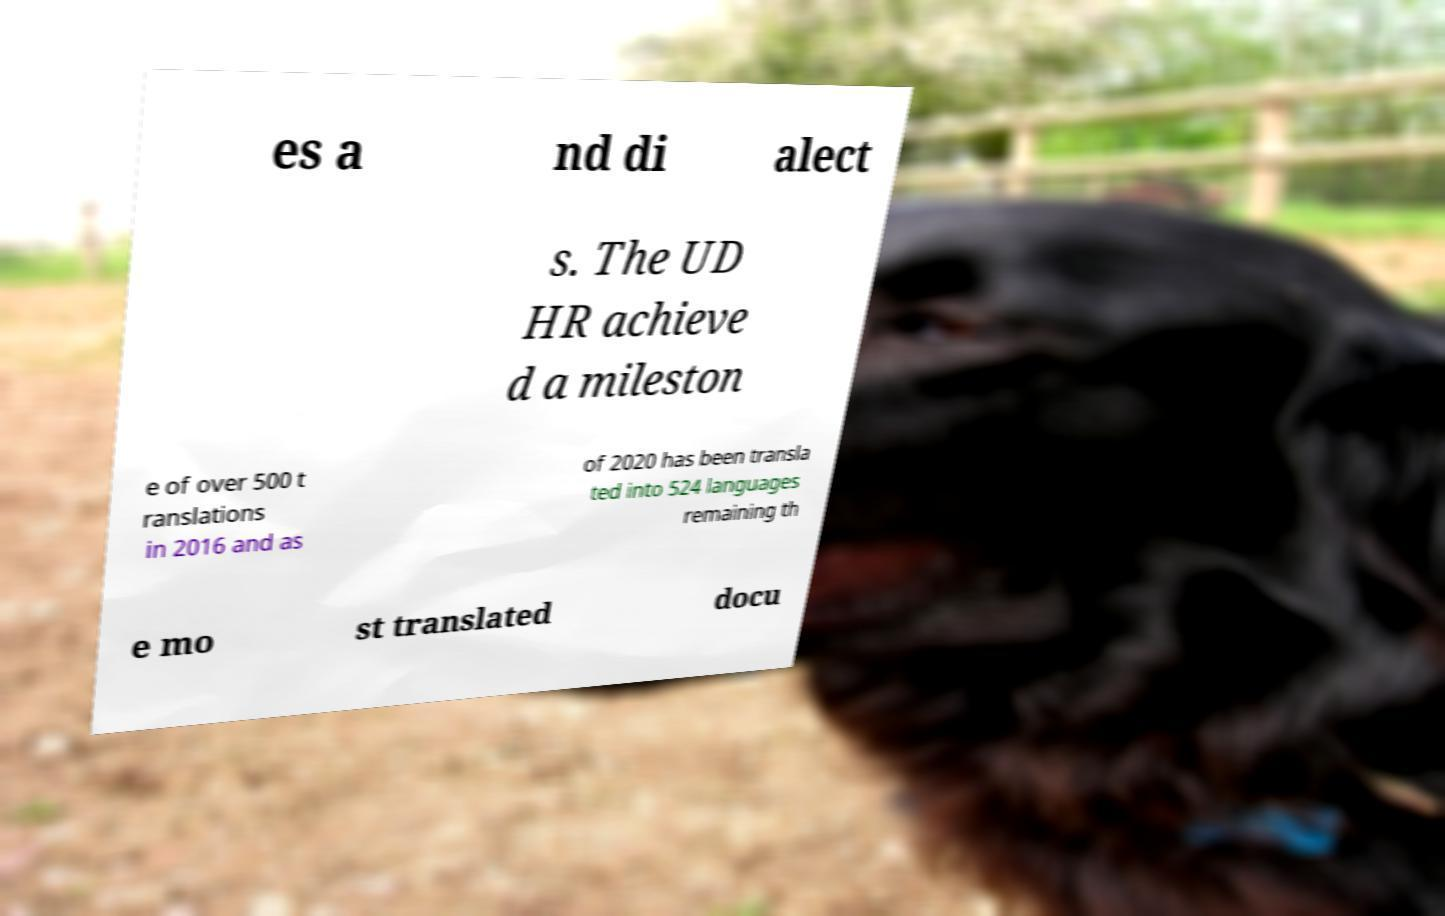What messages or text are displayed in this image? I need them in a readable, typed format. es a nd di alect s. The UD HR achieve d a mileston e of over 500 t ranslations in 2016 and as of 2020 has been transla ted into 524 languages remaining th e mo st translated docu 